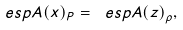<formula> <loc_0><loc_0><loc_500><loc_500>\ e s p { A ( x ) } _ { P } = \ e s p { A ( z ) } _ { \rho } ,</formula> 